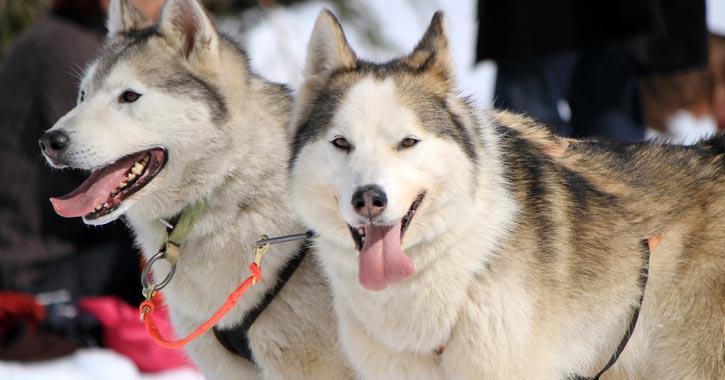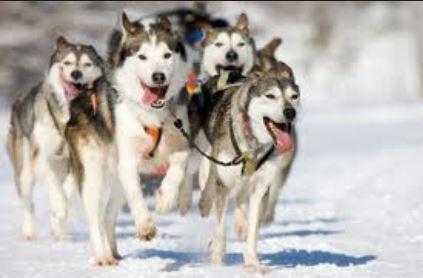The first image is the image on the left, the second image is the image on the right. Examine the images to the left and right. Is the description "Exactly one of the lead dogs has both front paws off the ground." accurate? Answer yes or no. Yes. The first image is the image on the left, the second image is the image on the right. For the images shown, is this caption "The right image features multiple husky dogs with dark-and-white fur and no booties racing toward the camera with tongues hanging out." true? Answer yes or no. Yes. 